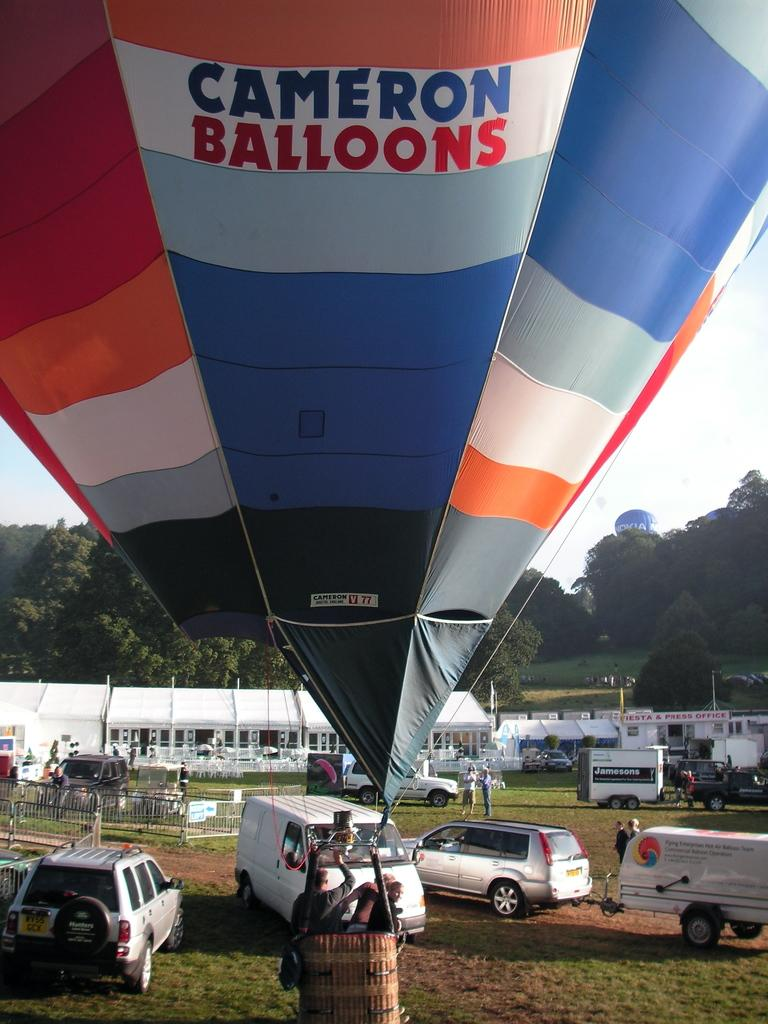<image>
Give a short and clear explanation of the subsequent image. A multicolored hot hair balloon that says Cameron Balloons on the front. 